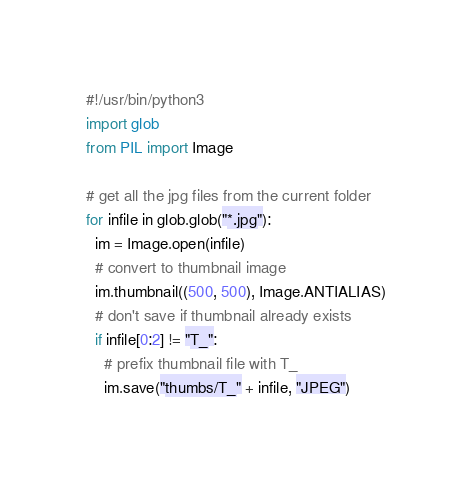Convert code to text. <code><loc_0><loc_0><loc_500><loc_500><_Python_>#!/usr/bin/python3
import glob
from PIL import Image

# get all the jpg files from the current folder
for infile in glob.glob("*.jpg"):
  im = Image.open(infile)
  # convert to thumbnail image
  im.thumbnail((500, 500), Image.ANTIALIAS)
  # don't save if thumbnail already exists
  if infile[0:2] != "T_":
    # prefix thumbnail file with T_
    im.save("thumbs/T_" + infile, "JPEG")
</code> 